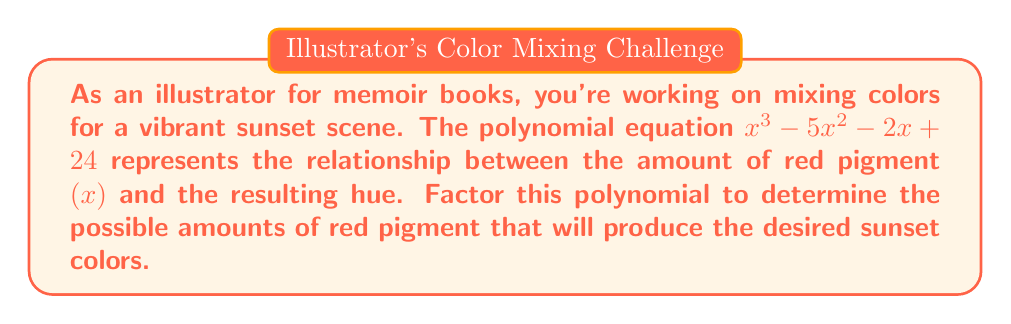What is the answer to this math problem? To factor this polynomial, let's follow these steps:

1) First, check if there are any common factors. In this case, there are none.

2) Next, we can try the rational root theorem. The possible rational roots are the factors of the constant term (24): ±1, ±2, ±3, ±4, ±6, ±8, ±12, ±24.

3) Testing these values, we find that x = 4 is a root. So (x - 4) is a factor.

4) Divide the polynomial by (x - 4):

   $$(x^3 - 5x^2 - 2x + 24) ÷ (x - 4) = x^2 - x - 6$$

5) Now we need to factor $x^2 - x - 6$. This is a quadratic equation.

6) For a quadratic in the form $ax^2 + bx + c$, we're looking for two numbers that multiply to give $ac$ (-6) and add to give $b$ (-1).

7) The numbers that satisfy this are -3 and 2.

8) Therefore, $x^2 - x - 6$ can be factored as $(x - 3)(x + 2)$.

9) Combining all factors, we get:

   $x^3 - 5x^2 - 2x + 24 = (x - 4)(x - 3)(x + 2)$

This factorization shows that the possible amounts of red pigment to produce the desired sunset colors are 4, 3, and -2 units.
Answer: $(x - 4)(x - 3)(x + 2)$ 